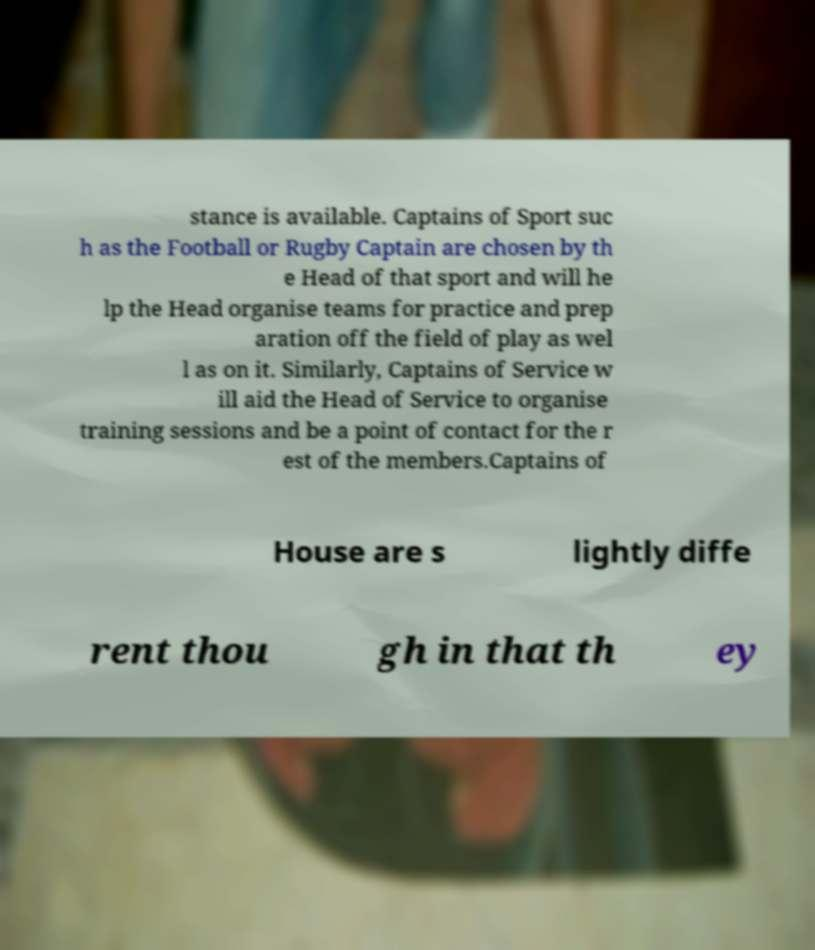Could you extract and type out the text from this image? stance is available. Captains of Sport suc h as the Football or Rugby Captain are chosen by th e Head of that sport and will he lp the Head organise teams for practice and prep aration off the field of play as wel l as on it. Similarly, Captains of Service w ill aid the Head of Service to organise training sessions and be a point of contact for the r est of the members.Captains of House are s lightly diffe rent thou gh in that th ey 